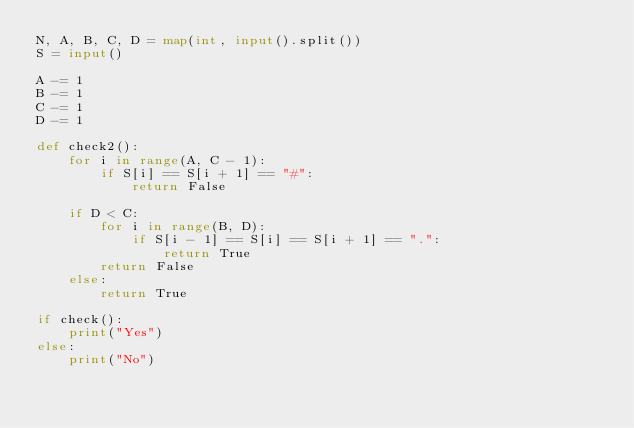<code> <loc_0><loc_0><loc_500><loc_500><_Python_>N, A, B, C, D = map(int, input().split())
S = input()

A -= 1
B -= 1
C -= 1
D -= 1

def check2():
	for i in range(A, C - 1):
		if S[i] == S[i + 1] == "#":
			return False
	
	if D < C:
		for i in range(B, D):
			if S[i - 1] == S[i] == S[i + 1] == ".":
				return True
		return False
	else:
		return True

if check():
	print("Yes")
else:
	print("No")
</code> 